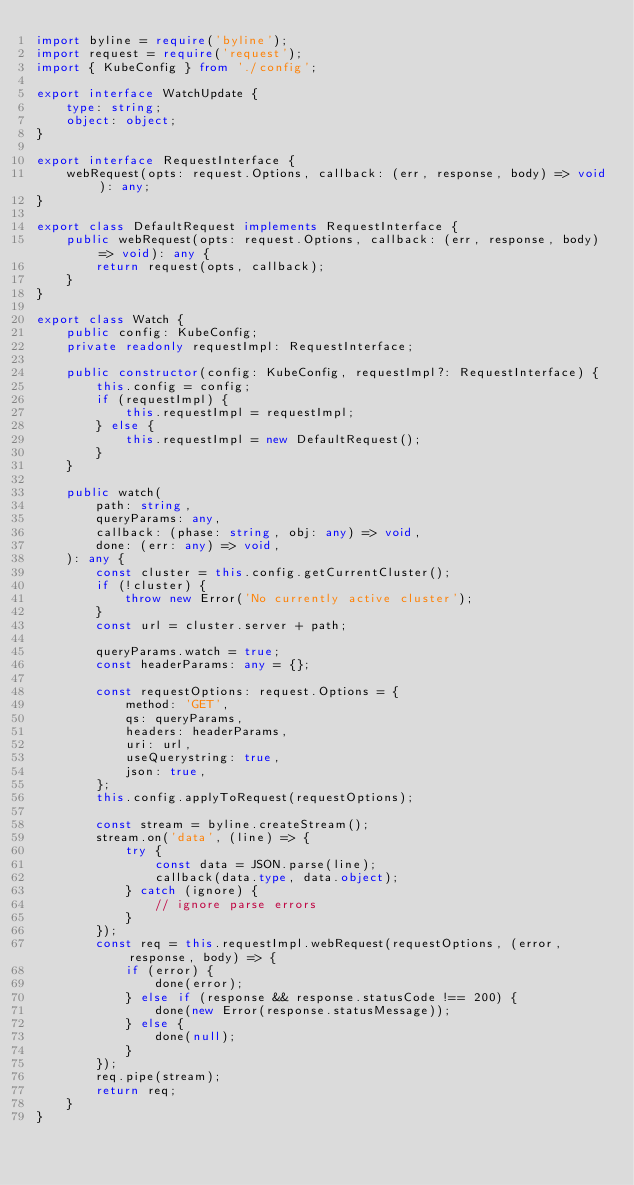Convert code to text. <code><loc_0><loc_0><loc_500><loc_500><_TypeScript_>import byline = require('byline');
import request = require('request');
import { KubeConfig } from './config';

export interface WatchUpdate {
    type: string;
    object: object;
}

export interface RequestInterface {
    webRequest(opts: request.Options, callback: (err, response, body) => void): any;
}

export class DefaultRequest implements RequestInterface {
    public webRequest(opts: request.Options, callback: (err, response, body) => void): any {
        return request(opts, callback);
    }
}

export class Watch {
    public config: KubeConfig;
    private readonly requestImpl: RequestInterface;

    public constructor(config: KubeConfig, requestImpl?: RequestInterface) {
        this.config = config;
        if (requestImpl) {
            this.requestImpl = requestImpl;
        } else {
            this.requestImpl = new DefaultRequest();
        }
    }

    public watch(
        path: string,
        queryParams: any,
        callback: (phase: string, obj: any) => void,
        done: (err: any) => void,
    ): any {
        const cluster = this.config.getCurrentCluster();
        if (!cluster) {
            throw new Error('No currently active cluster');
        }
        const url = cluster.server + path;

        queryParams.watch = true;
        const headerParams: any = {};

        const requestOptions: request.Options = {
            method: 'GET',
            qs: queryParams,
            headers: headerParams,
            uri: url,
            useQuerystring: true,
            json: true,
        };
        this.config.applyToRequest(requestOptions);

        const stream = byline.createStream();
        stream.on('data', (line) => {
            try {
                const data = JSON.parse(line);
                callback(data.type, data.object);
            } catch (ignore) {
                // ignore parse errors
            }
        });
        const req = this.requestImpl.webRequest(requestOptions, (error, response, body) => {
            if (error) {
                done(error);
            } else if (response && response.statusCode !== 200) {
                done(new Error(response.statusMessage));
            } else {
                done(null);
            }
        });
        req.pipe(stream);
        return req;
    }
}
</code> 